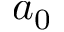<formula> <loc_0><loc_0><loc_500><loc_500>a _ { 0 }</formula> 